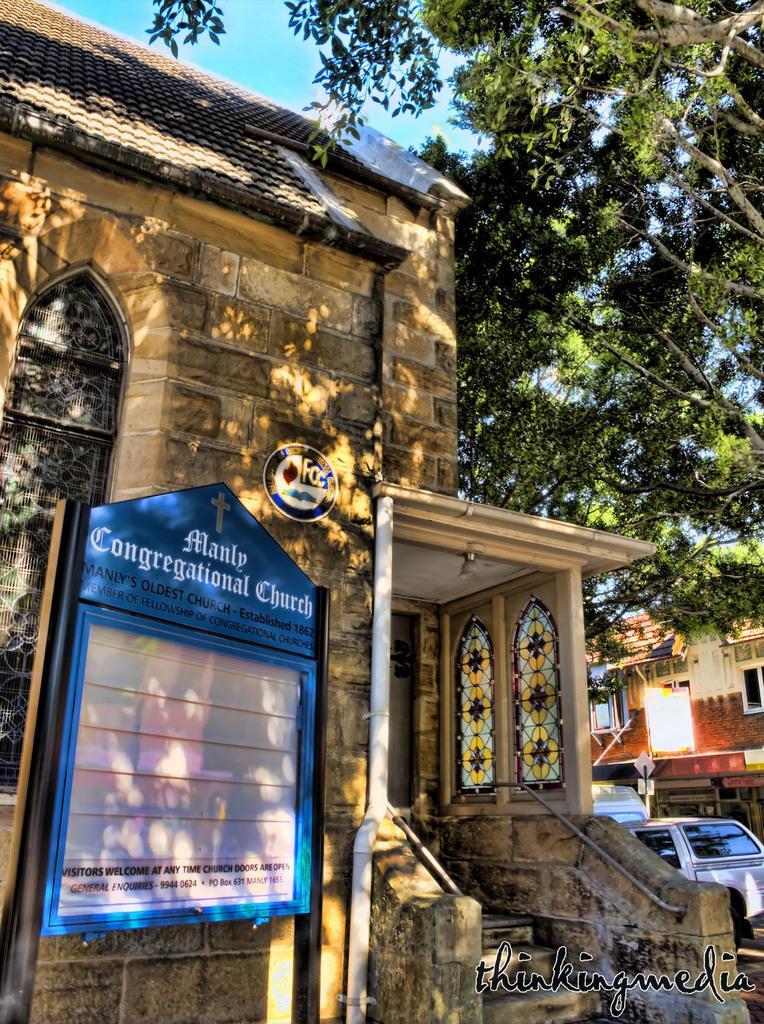Could you give a brief overview of what you see in this image? In this image I can see a church, on the left side there is a board. On the right side there is a tree, at the top it is the sky. 